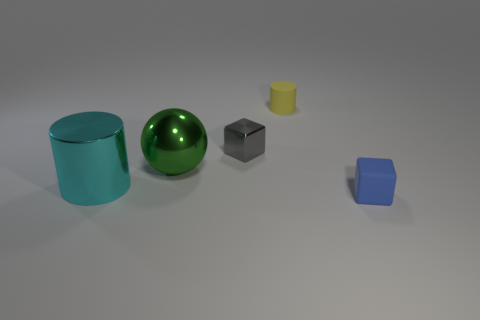There is another object that is the same shape as the cyan shiny object; what size is it?
Your answer should be very brief. Small. Are there fewer small cylinders to the left of the small yellow rubber cylinder than tiny yellow matte things?
Your response must be concise. Yes. Are any matte cylinders visible?
Offer a terse response. Yes. The other small thing that is the same shape as the blue matte thing is what color?
Offer a terse response. Gray. Does the small thing that is in front of the green sphere have the same color as the large sphere?
Your answer should be very brief. No. Do the blue rubber block and the gray metal block have the same size?
Provide a succinct answer. Yes. There is a small yellow object that is made of the same material as the blue thing; what is its shape?
Provide a succinct answer. Cylinder. How many other objects are the same shape as the large cyan object?
Give a very brief answer. 1. What is the shape of the small thing that is in front of the ball that is right of the cylinder that is left of the gray thing?
Offer a terse response. Cube. How many spheres are small brown rubber objects or large objects?
Offer a terse response. 1. 